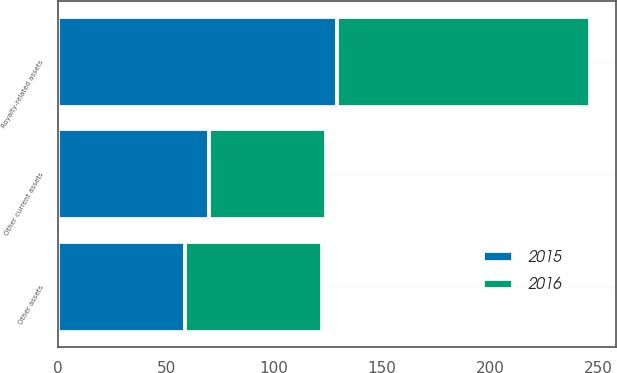<chart> <loc_0><loc_0><loc_500><loc_500><stacked_bar_chart><ecel><fcel>Other current assets<fcel>Other assets<fcel>Royalty-related assets<nl><fcel>2016<fcel>54<fcel>63<fcel>117<nl><fcel>2015<fcel>70<fcel>59<fcel>129<nl></chart> 